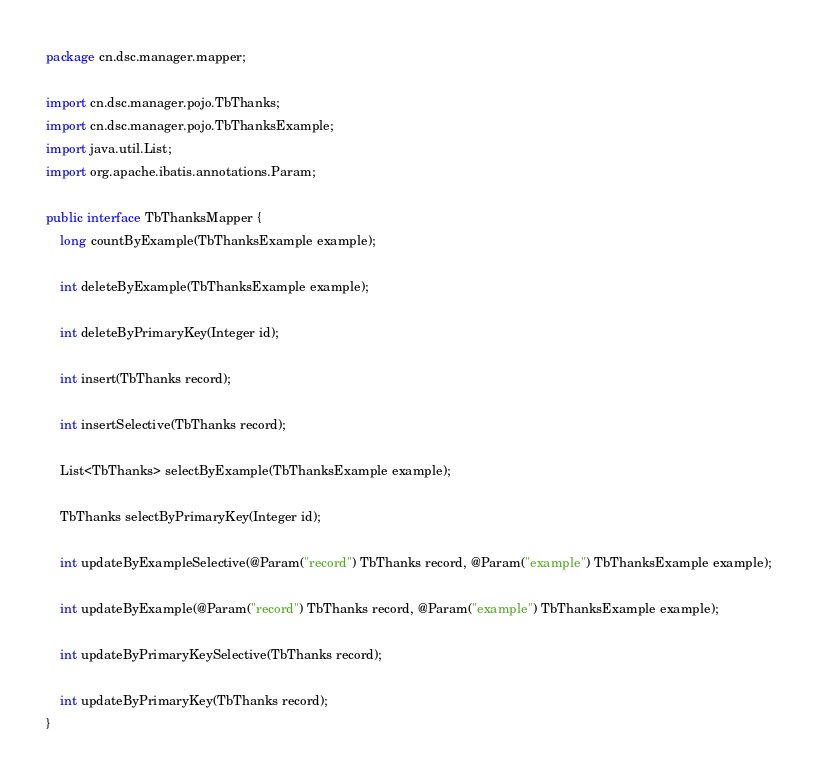<code> <loc_0><loc_0><loc_500><loc_500><_Java_>package cn.dsc.manager.mapper;

import cn.dsc.manager.pojo.TbThanks;
import cn.dsc.manager.pojo.TbThanksExample;
import java.util.List;
import org.apache.ibatis.annotations.Param;

public interface TbThanksMapper {
    long countByExample(TbThanksExample example);

    int deleteByExample(TbThanksExample example);

    int deleteByPrimaryKey(Integer id);

    int insert(TbThanks record);

    int insertSelective(TbThanks record);

    List<TbThanks> selectByExample(TbThanksExample example);

    TbThanks selectByPrimaryKey(Integer id);

    int updateByExampleSelective(@Param("record") TbThanks record, @Param("example") TbThanksExample example);

    int updateByExample(@Param("record") TbThanks record, @Param("example") TbThanksExample example);

    int updateByPrimaryKeySelective(TbThanks record);

    int updateByPrimaryKey(TbThanks record);
}</code> 